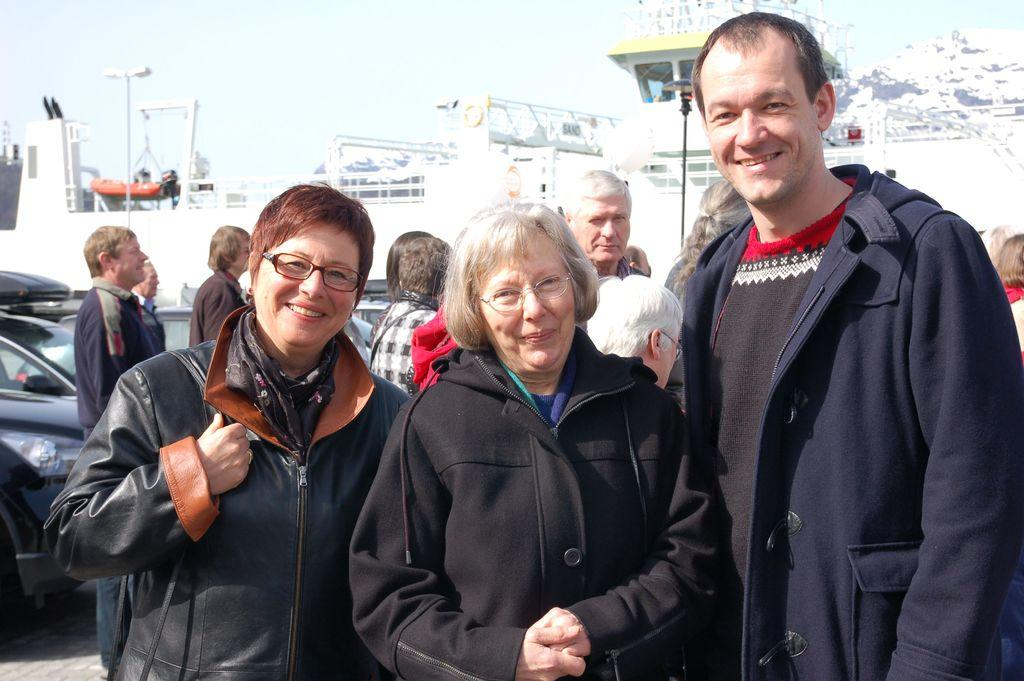What is happening in the image? There are people standing in the image. Can you describe the location of the people in the image? Some people are standing in the background of the image. What else can be seen in the background of the image? Cars are visible in the background of the image. What is visible at the top of the image? The sky is visible at the top of the image. What type of bomb can be seen exploding in the image? There is no bomb present in the image; it features people standing and cars in the background. What songs are the people singing in the image? There is no indication in the image that the people are singing songs, so it cannot be determined from the picture. 